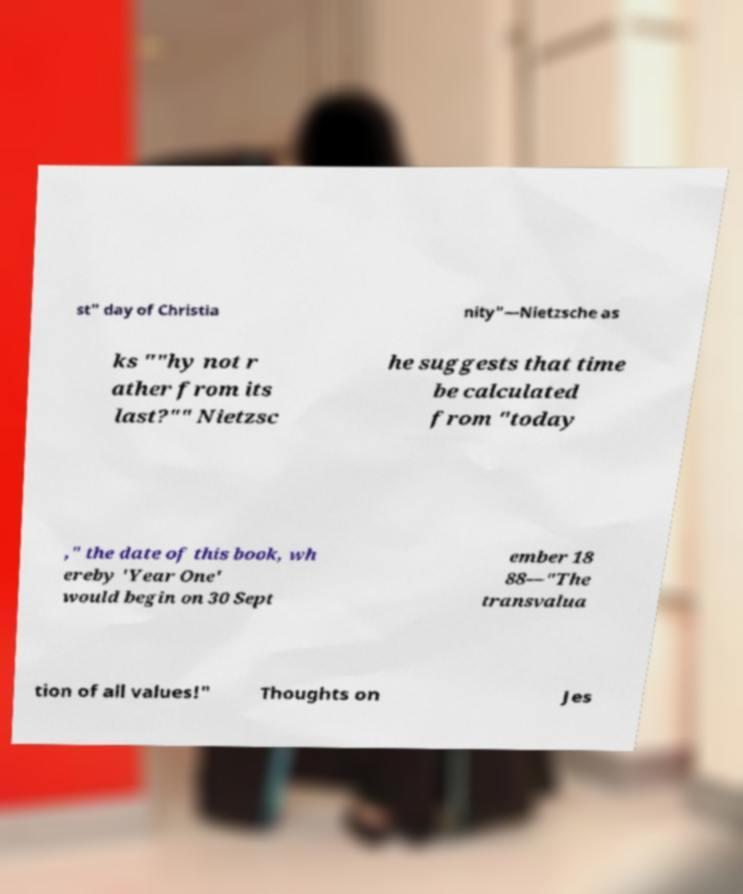For documentation purposes, I need the text within this image transcribed. Could you provide that? st" day of Christia nity"—Nietzsche as ks ""hy not r ather from its last?"" Nietzsc he suggests that time be calculated from "today ," the date of this book, wh ereby 'Year One' would begin on 30 Sept ember 18 88—"The transvalua tion of all values!" Thoughts on Jes 